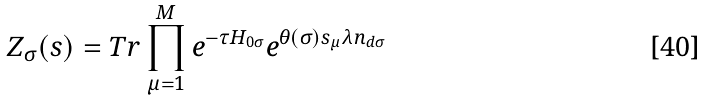<formula> <loc_0><loc_0><loc_500><loc_500>Z _ { \sigma } ( { s } ) = T r \prod _ { \mu = 1 } ^ { M } e ^ { - \tau H _ { 0 \sigma } } e ^ { \theta ( \sigma ) s _ { \mu } \lambda n _ { d \sigma } }</formula> 